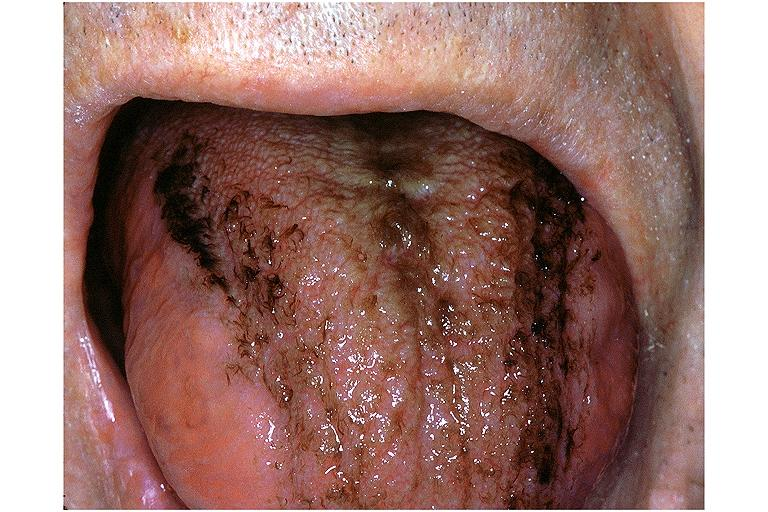does this image show black hairy tongue?
Answer the question using a single word or phrase. Yes 